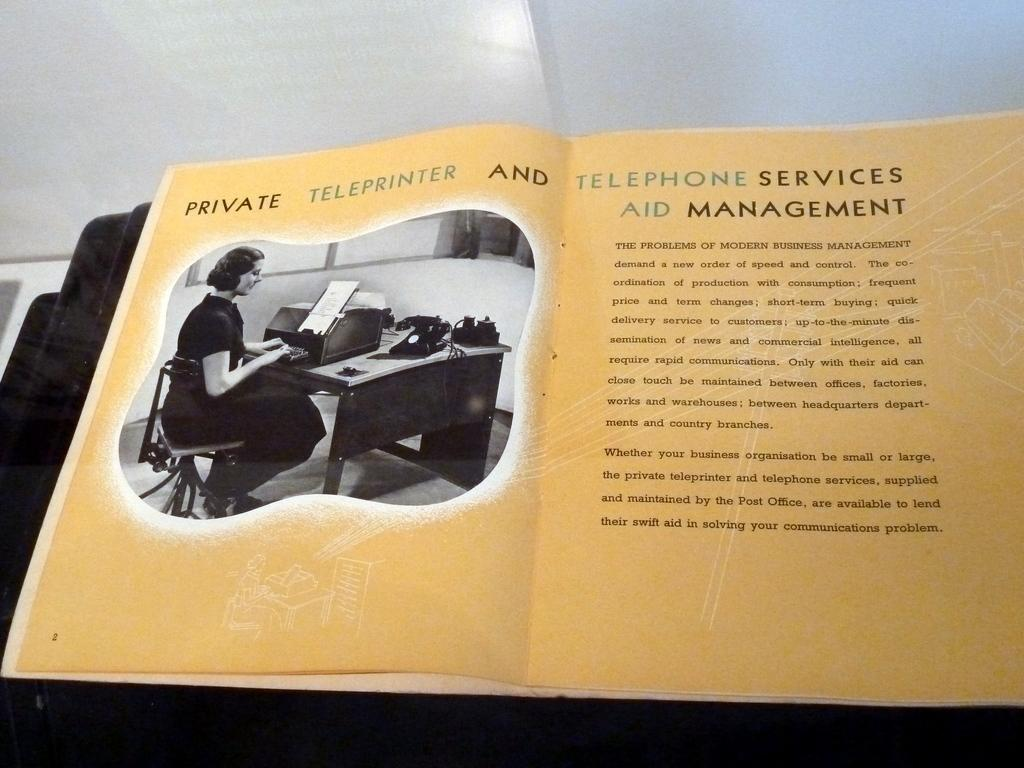<image>
Describe the image concisely. The books shown is opened to page 2. 